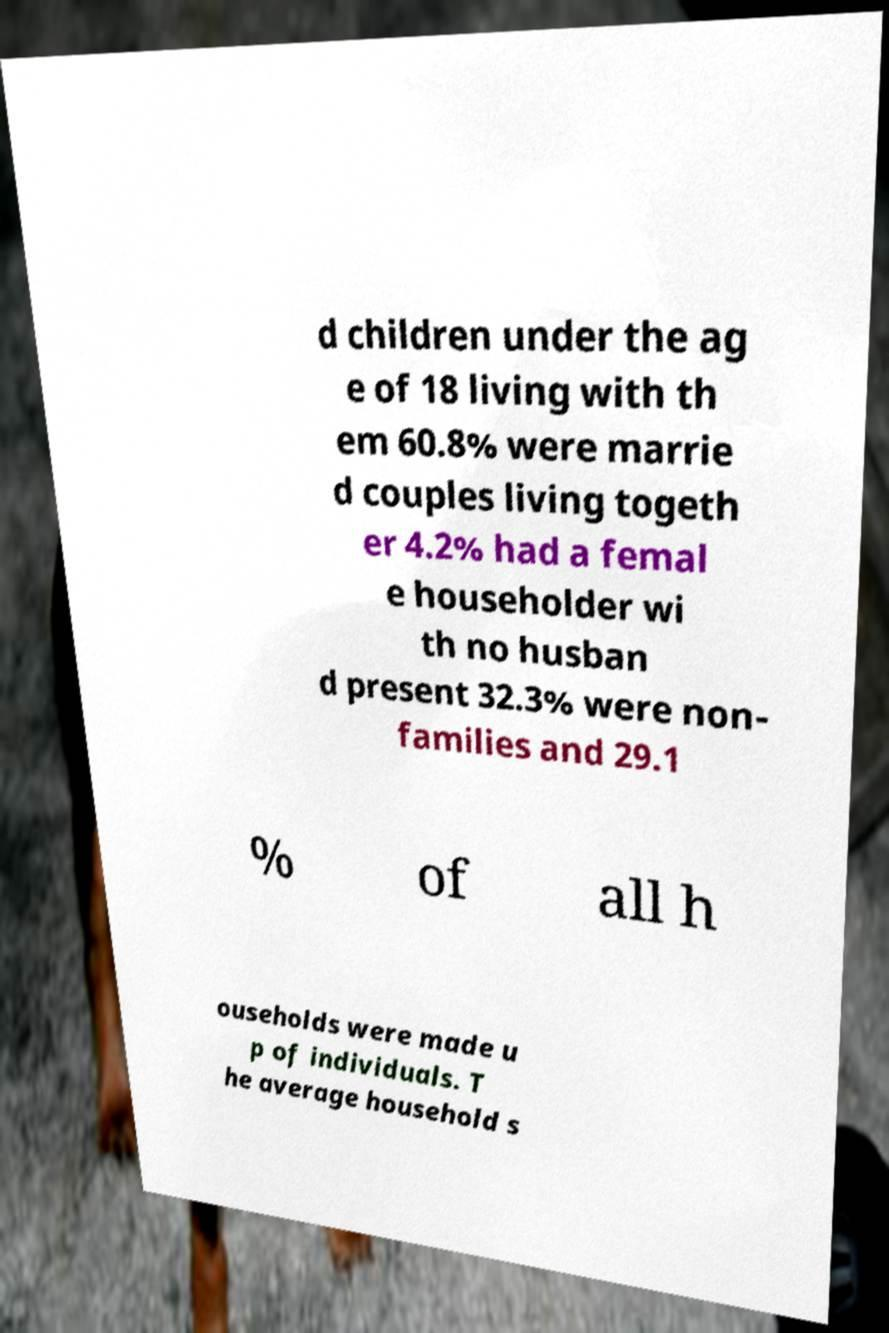Could you extract and type out the text from this image? d children under the ag e of 18 living with th em 60.8% were marrie d couples living togeth er 4.2% had a femal e householder wi th no husban d present 32.3% were non- families and 29.1 % of all h ouseholds were made u p of individuals. T he average household s 